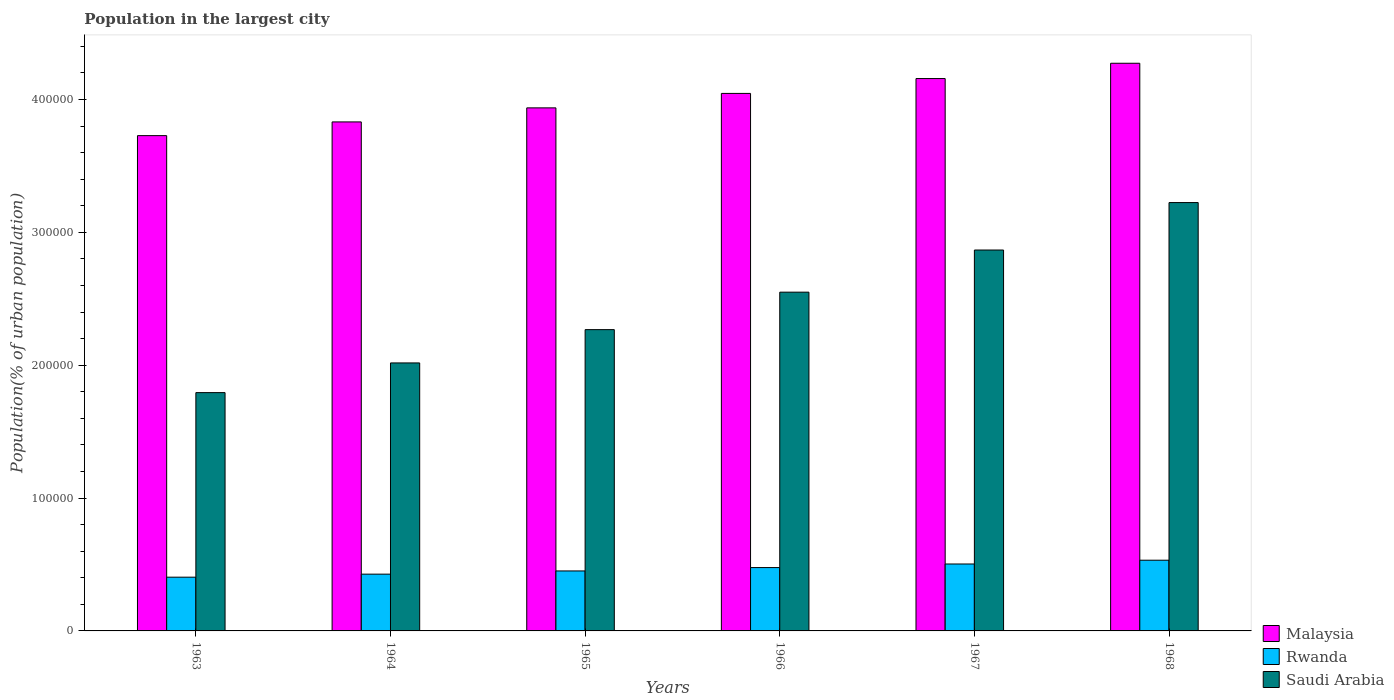Are the number of bars on each tick of the X-axis equal?
Provide a succinct answer. Yes. How many bars are there on the 2nd tick from the left?
Provide a succinct answer. 3. What is the label of the 2nd group of bars from the left?
Your answer should be very brief. 1964. In how many cases, is the number of bars for a given year not equal to the number of legend labels?
Your answer should be compact. 0. What is the population in the largest city in Saudi Arabia in 1967?
Keep it short and to the point. 2.87e+05. Across all years, what is the maximum population in the largest city in Malaysia?
Provide a short and direct response. 4.27e+05. Across all years, what is the minimum population in the largest city in Malaysia?
Make the answer very short. 3.73e+05. In which year was the population in the largest city in Rwanda maximum?
Make the answer very short. 1968. What is the total population in the largest city in Saudi Arabia in the graph?
Make the answer very short. 1.47e+06. What is the difference between the population in the largest city in Malaysia in 1963 and that in 1966?
Make the answer very short. -3.18e+04. What is the difference between the population in the largest city in Saudi Arabia in 1965 and the population in the largest city in Rwanda in 1966?
Offer a terse response. 1.79e+05. What is the average population in the largest city in Saudi Arabia per year?
Give a very brief answer. 2.45e+05. In the year 1964, what is the difference between the population in the largest city in Malaysia and population in the largest city in Rwanda?
Give a very brief answer. 3.40e+05. In how many years, is the population in the largest city in Rwanda greater than 180000 %?
Provide a short and direct response. 0. What is the ratio of the population in the largest city in Rwanda in 1966 to that in 1968?
Your response must be concise. 0.9. Is the population in the largest city in Saudi Arabia in 1963 less than that in 1964?
Your answer should be compact. Yes. What is the difference between the highest and the second highest population in the largest city in Malaysia?
Your response must be concise. 1.15e+04. What is the difference between the highest and the lowest population in the largest city in Rwanda?
Offer a terse response. 1.28e+04. Is the sum of the population in the largest city in Rwanda in 1966 and 1967 greater than the maximum population in the largest city in Saudi Arabia across all years?
Provide a succinct answer. No. What does the 2nd bar from the left in 1963 represents?
Give a very brief answer. Rwanda. What does the 2nd bar from the right in 1964 represents?
Provide a short and direct response. Rwanda. Is it the case that in every year, the sum of the population in the largest city in Saudi Arabia and population in the largest city in Malaysia is greater than the population in the largest city in Rwanda?
Ensure brevity in your answer.  Yes. Are all the bars in the graph horizontal?
Offer a terse response. No. Where does the legend appear in the graph?
Keep it short and to the point. Bottom right. How many legend labels are there?
Keep it short and to the point. 3. How are the legend labels stacked?
Your answer should be compact. Vertical. What is the title of the graph?
Your answer should be very brief. Population in the largest city. Does "Isle of Man" appear as one of the legend labels in the graph?
Offer a very short reply. No. What is the label or title of the X-axis?
Your response must be concise. Years. What is the label or title of the Y-axis?
Your answer should be very brief. Population(% of urban population). What is the Population(% of urban population) of Malaysia in 1963?
Offer a terse response. 3.73e+05. What is the Population(% of urban population) in Rwanda in 1963?
Offer a very short reply. 4.05e+04. What is the Population(% of urban population) in Saudi Arabia in 1963?
Your answer should be very brief. 1.79e+05. What is the Population(% of urban population) of Malaysia in 1964?
Provide a succinct answer. 3.83e+05. What is the Population(% of urban population) of Rwanda in 1964?
Give a very brief answer. 4.27e+04. What is the Population(% of urban population) in Saudi Arabia in 1964?
Your response must be concise. 2.02e+05. What is the Population(% of urban population) of Malaysia in 1965?
Make the answer very short. 3.94e+05. What is the Population(% of urban population) of Rwanda in 1965?
Give a very brief answer. 4.51e+04. What is the Population(% of urban population) of Saudi Arabia in 1965?
Ensure brevity in your answer.  2.27e+05. What is the Population(% of urban population) in Malaysia in 1966?
Your answer should be compact. 4.05e+05. What is the Population(% of urban population) in Rwanda in 1966?
Provide a short and direct response. 4.77e+04. What is the Population(% of urban population) in Saudi Arabia in 1966?
Your answer should be very brief. 2.55e+05. What is the Population(% of urban population) in Malaysia in 1967?
Make the answer very short. 4.16e+05. What is the Population(% of urban population) of Rwanda in 1967?
Your answer should be compact. 5.04e+04. What is the Population(% of urban population) of Saudi Arabia in 1967?
Offer a very short reply. 2.87e+05. What is the Population(% of urban population) of Malaysia in 1968?
Provide a succinct answer. 4.27e+05. What is the Population(% of urban population) in Rwanda in 1968?
Provide a short and direct response. 5.32e+04. What is the Population(% of urban population) of Saudi Arabia in 1968?
Your response must be concise. 3.22e+05. Across all years, what is the maximum Population(% of urban population) of Malaysia?
Make the answer very short. 4.27e+05. Across all years, what is the maximum Population(% of urban population) of Rwanda?
Offer a very short reply. 5.32e+04. Across all years, what is the maximum Population(% of urban population) in Saudi Arabia?
Provide a succinct answer. 3.22e+05. Across all years, what is the minimum Population(% of urban population) in Malaysia?
Give a very brief answer. 3.73e+05. Across all years, what is the minimum Population(% of urban population) of Rwanda?
Your answer should be compact. 4.05e+04. Across all years, what is the minimum Population(% of urban population) in Saudi Arabia?
Provide a succinct answer. 1.79e+05. What is the total Population(% of urban population) of Malaysia in the graph?
Keep it short and to the point. 2.40e+06. What is the total Population(% of urban population) in Rwanda in the graph?
Offer a very short reply. 2.80e+05. What is the total Population(% of urban population) of Saudi Arabia in the graph?
Give a very brief answer. 1.47e+06. What is the difference between the Population(% of urban population) of Malaysia in 1963 and that in 1964?
Keep it short and to the point. -1.03e+04. What is the difference between the Population(% of urban population) in Rwanda in 1963 and that in 1964?
Your response must be concise. -2284. What is the difference between the Population(% of urban population) of Saudi Arabia in 1963 and that in 1964?
Give a very brief answer. -2.23e+04. What is the difference between the Population(% of urban population) of Malaysia in 1963 and that in 1965?
Provide a succinct answer. -2.09e+04. What is the difference between the Population(% of urban population) of Rwanda in 1963 and that in 1965?
Keep it short and to the point. -4690. What is the difference between the Population(% of urban population) of Saudi Arabia in 1963 and that in 1965?
Offer a terse response. -4.74e+04. What is the difference between the Population(% of urban population) in Malaysia in 1963 and that in 1966?
Make the answer very short. -3.18e+04. What is the difference between the Population(% of urban population) of Rwanda in 1963 and that in 1966?
Provide a succinct answer. -7235. What is the difference between the Population(% of urban population) in Saudi Arabia in 1963 and that in 1966?
Your answer should be very brief. -7.56e+04. What is the difference between the Population(% of urban population) in Malaysia in 1963 and that in 1967?
Your response must be concise. -4.30e+04. What is the difference between the Population(% of urban population) of Rwanda in 1963 and that in 1967?
Offer a very short reply. -9924. What is the difference between the Population(% of urban population) of Saudi Arabia in 1963 and that in 1967?
Your answer should be very brief. -1.07e+05. What is the difference between the Population(% of urban population) of Malaysia in 1963 and that in 1968?
Your response must be concise. -5.45e+04. What is the difference between the Population(% of urban population) in Rwanda in 1963 and that in 1968?
Offer a terse response. -1.28e+04. What is the difference between the Population(% of urban population) of Saudi Arabia in 1963 and that in 1968?
Provide a succinct answer. -1.43e+05. What is the difference between the Population(% of urban population) in Malaysia in 1964 and that in 1965?
Give a very brief answer. -1.06e+04. What is the difference between the Population(% of urban population) in Rwanda in 1964 and that in 1965?
Your answer should be compact. -2406. What is the difference between the Population(% of urban population) in Saudi Arabia in 1964 and that in 1965?
Offer a terse response. -2.51e+04. What is the difference between the Population(% of urban population) of Malaysia in 1964 and that in 1966?
Your answer should be compact. -2.15e+04. What is the difference between the Population(% of urban population) in Rwanda in 1964 and that in 1966?
Make the answer very short. -4951. What is the difference between the Population(% of urban population) in Saudi Arabia in 1964 and that in 1966?
Your response must be concise. -5.33e+04. What is the difference between the Population(% of urban population) of Malaysia in 1964 and that in 1967?
Provide a succinct answer. -3.26e+04. What is the difference between the Population(% of urban population) in Rwanda in 1964 and that in 1967?
Offer a very short reply. -7640. What is the difference between the Population(% of urban population) in Saudi Arabia in 1964 and that in 1967?
Offer a very short reply. -8.50e+04. What is the difference between the Population(% of urban population) of Malaysia in 1964 and that in 1968?
Give a very brief answer. -4.42e+04. What is the difference between the Population(% of urban population) of Rwanda in 1964 and that in 1968?
Make the answer very short. -1.05e+04. What is the difference between the Population(% of urban population) of Saudi Arabia in 1964 and that in 1968?
Offer a very short reply. -1.21e+05. What is the difference between the Population(% of urban population) in Malaysia in 1965 and that in 1966?
Your answer should be compact. -1.09e+04. What is the difference between the Population(% of urban population) of Rwanda in 1965 and that in 1966?
Give a very brief answer. -2545. What is the difference between the Population(% of urban population) in Saudi Arabia in 1965 and that in 1966?
Your response must be concise. -2.82e+04. What is the difference between the Population(% of urban population) of Malaysia in 1965 and that in 1967?
Offer a terse response. -2.21e+04. What is the difference between the Population(% of urban population) in Rwanda in 1965 and that in 1967?
Keep it short and to the point. -5234. What is the difference between the Population(% of urban population) of Saudi Arabia in 1965 and that in 1967?
Ensure brevity in your answer.  -5.99e+04. What is the difference between the Population(% of urban population) in Malaysia in 1965 and that in 1968?
Your answer should be very brief. -3.36e+04. What is the difference between the Population(% of urban population) of Rwanda in 1965 and that in 1968?
Keep it short and to the point. -8077. What is the difference between the Population(% of urban population) of Saudi Arabia in 1965 and that in 1968?
Provide a succinct answer. -9.56e+04. What is the difference between the Population(% of urban population) of Malaysia in 1966 and that in 1967?
Offer a very short reply. -1.12e+04. What is the difference between the Population(% of urban population) in Rwanda in 1966 and that in 1967?
Make the answer very short. -2689. What is the difference between the Population(% of urban population) of Saudi Arabia in 1966 and that in 1967?
Your answer should be very brief. -3.17e+04. What is the difference between the Population(% of urban population) in Malaysia in 1966 and that in 1968?
Give a very brief answer. -2.27e+04. What is the difference between the Population(% of urban population) of Rwanda in 1966 and that in 1968?
Keep it short and to the point. -5532. What is the difference between the Population(% of urban population) of Saudi Arabia in 1966 and that in 1968?
Offer a very short reply. -6.74e+04. What is the difference between the Population(% of urban population) in Malaysia in 1967 and that in 1968?
Provide a short and direct response. -1.15e+04. What is the difference between the Population(% of urban population) in Rwanda in 1967 and that in 1968?
Your answer should be very brief. -2843. What is the difference between the Population(% of urban population) in Saudi Arabia in 1967 and that in 1968?
Your answer should be very brief. -3.57e+04. What is the difference between the Population(% of urban population) in Malaysia in 1963 and the Population(% of urban population) in Rwanda in 1964?
Make the answer very short. 3.30e+05. What is the difference between the Population(% of urban population) in Malaysia in 1963 and the Population(% of urban population) in Saudi Arabia in 1964?
Keep it short and to the point. 1.71e+05. What is the difference between the Population(% of urban population) of Rwanda in 1963 and the Population(% of urban population) of Saudi Arabia in 1964?
Provide a short and direct response. -1.61e+05. What is the difference between the Population(% of urban population) in Malaysia in 1963 and the Population(% of urban population) in Rwanda in 1965?
Offer a terse response. 3.28e+05. What is the difference between the Population(% of urban population) of Malaysia in 1963 and the Population(% of urban population) of Saudi Arabia in 1965?
Keep it short and to the point. 1.46e+05. What is the difference between the Population(% of urban population) in Rwanda in 1963 and the Population(% of urban population) in Saudi Arabia in 1965?
Provide a short and direct response. -1.86e+05. What is the difference between the Population(% of urban population) in Malaysia in 1963 and the Population(% of urban population) in Rwanda in 1966?
Offer a very short reply. 3.25e+05. What is the difference between the Population(% of urban population) of Malaysia in 1963 and the Population(% of urban population) of Saudi Arabia in 1966?
Provide a succinct answer. 1.18e+05. What is the difference between the Population(% of urban population) of Rwanda in 1963 and the Population(% of urban population) of Saudi Arabia in 1966?
Keep it short and to the point. -2.15e+05. What is the difference between the Population(% of urban population) in Malaysia in 1963 and the Population(% of urban population) in Rwanda in 1967?
Your answer should be compact. 3.22e+05. What is the difference between the Population(% of urban population) in Malaysia in 1963 and the Population(% of urban population) in Saudi Arabia in 1967?
Keep it short and to the point. 8.61e+04. What is the difference between the Population(% of urban population) in Rwanda in 1963 and the Population(% of urban population) in Saudi Arabia in 1967?
Offer a terse response. -2.46e+05. What is the difference between the Population(% of urban population) of Malaysia in 1963 and the Population(% of urban population) of Rwanda in 1968?
Provide a short and direct response. 3.20e+05. What is the difference between the Population(% of urban population) of Malaysia in 1963 and the Population(% of urban population) of Saudi Arabia in 1968?
Offer a very short reply. 5.04e+04. What is the difference between the Population(% of urban population) in Rwanda in 1963 and the Population(% of urban population) in Saudi Arabia in 1968?
Provide a short and direct response. -2.82e+05. What is the difference between the Population(% of urban population) of Malaysia in 1964 and the Population(% of urban population) of Rwanda in 1965?
Make the answer very short. 3.38e+05. What is the difference between the Population(% of urban population) in Malaysia in 1964 and the Population(% of urban population) in Saudi Arabia in 1965?
Keep it short and to the point. 1.56e+05. What is the difference between the Population(% of urban population) in Rwanda in 1964 and the Population(% of urban population) in Saudi Arabia in 1965?
Give a very brief answer. -1.84e+05. What is the difference between the Population(% of urban population) in Malaysia in 1964 and the Population(% of urban population) in Rwanda in 1966?
Keep it short and to the point. 3.35e+05. What is the difference between the Population(% of urban population) of Malaysia in 1964 and the Population(% of urban population) of Saudi Arabia in 1966?
Offer a very short reply. 1.28e+05. What is the difference between the Population(% of urban population) in Rwanda in 1964 and the Population(% of urban population) in Saudi Arabia in 1966?
Provide a succinct answer. -2.12e+05. What is the difference between the Population(% of urban population) in Malaysia in 1964 and the Population(% of urban population) in Rwanda in 1967?
Offer a very short reply. 3.33e+05. What is the difference between the Population(% of urban population) in Malaysia in 1964 and the Population(% of urban population) in Saudi Arabia in 1967?
Your response must be concise. 9.64e+04. What is the difference between the Population(% of urban population) in Rwanda in 1964 and the Population(% of urban population) in Saudi Arabia in 1967?
Your answer should be compact. -2.44e+05. What is the difference between the Population(% of urban population) in Malaysia in 1964 and the Population(% of urban population) in Rwanda in 1968?
Make the answer very short. 3.30e+05. What is the difference between the Population(% of urban population) of Malaysia in 1964 and the Population(% of urban population) of Saudi Arabia in 1968?
Offer a very short reply. 6.07e+04. What is the difference between the Population(% of urban population) in Rwanda in 1964 and the Population(% of urban population) in Saudi Arabia in 1968?
Ensure brevity in your answer.  -2.80e+05. What is the difference between the Population(% of urban population) of Malaysia in 1965 and the Population(% of urban population) of Rwanda in 1966?
Provide a succinct answer. 3.46e+05. What is the difference between the Population(% of urban population) in Malaysia in 1965 and the Population(% of urban population) in Saudi Arabia in 1966?
Offer a terse response. 1.39e+05. What is the difference between the Population(% of urban population) of Rwanda in 1965 and the Population(% of urban population) of Saudi Arabia in 1966?
Provide a succinct answer. -2.10e+05. What is the difference between the Population(% of urban population) of Malaysia in 1965 and the Population(% of urban population) of Rwanda in 1967?
Provide a short and direct response. 3.43e+05. What is the difference between the Population(% of urban population) of Malaysia in 1965 and the Population(% of urban population) of Saudi Arabia in 1967?
Offer a terse response. 1.07e+05. What is the difference between the Population(% of urban population) of Rwanda in 1965 and the Population(% of urban population) of Saudi Arabia in 1967?
Offer a very short reply. -2.42e+05. What is the difference between the Population(% of urban population) of Malaysia in 1965 and the Population(% of urban population) of Rwanda in 1968?
Your answer should be very brief. 3.40e+05. What is the difference between the Population(% of urban population) of Malaysia in 1965 and the Population(% of urban population) of Saudi Arabia in 1968?
Keep it short and to the point. 7.13e+04. What is the difference between the Population(% of urban population) in Rwanda in 1965 and the Population(% of urban population) in Saudi Arabia in 1968?
Offer a terse response. -2.77e+05. What is the difference between the Population(% of urban population) in Malaysia in 1966 and the Population(% of urban population) in Rwanda in 1967?
Provide a short and direct response. 3.54e+05. What is the difference between the Population(% of urban population) in Malaysia in 1966 and the Population(% of urban population) in Saudi Arabia in 1967?
Your answer should be very brief. 1.18e+05. What is the difference between the Population(% of urban population) in Rwanda in 1966 and the Population(% of urban population) in Saudi Arabia in 1967?
Offer a very short reply. -2.39e+05. What is the difference between the Population(% of urban population) in Malaysia in 1966 and the Population(% of urban population) in Rwanda in 1968?
Offer a terse response. 3.51e+05. What is the difference between the Population(% of urban population) of Malaysia in 1966 and the Population(% of urban population) of Saudi Arabia in 1968?
Provide a short and direct response. 8.22e+04. What is the difference between the Population(% of urban population) of Rwanda in 1966 and the Population(% of urban population) of Saudi Arabia in 1968?
Make the answer very short. -2.75e+05. What is the difference between the Population(% of urban population) in Malaysia in 1967 and the Population(% of urban population) in Rwanda in 1968?
Your answer should be very brief. 3.63e+05. What is the difference between the Population(% of urban population) of Malaysia in 1967 and the Population(% of urban population) of Saudi Arabia in 1968?
Provide a succinct answer. 9.34e+04. What is the difference between the Population(% of urban population) in Rwanda in 1967 and the Population(% of urban population) in Saudi Arabia in 1968?
Provide a short and direct response. -2.72e+05. What is the average Population(% of urban population) of Malaysia per year?
Ensure brevity in your answer.  4.00e+05. What is the average Population(% of urban population) of Rwanda per year?
Your answer should be compact. 4.66e+04. What is the average Population(% of urban population) in Saudi Arabia per year?
Keep it short and to the point. 2.45e+05. In the year 1963, what is the difference between the Population(% of urban population) in Malaysia and Population(% of urban population) in Rwanda?
Provide a short and direct response. 3.32e+05. In the year 1963, what is the difference between the Population(% of urban population) of Malaysia and Population(% of urban population) of Saudi Arabia?
Offer a terse response. 1.93e+05. In the year 1963, what is the difference between the Population(% of urban population) of Rwanda and Population(% of urban population) of Saudi Arabia?
Offer a terse response. -1.39e+05. In the year 1964, what is the difference between the Population(% of urban population) of Malaysia and Population(% of urban population) of Rwanda?
Your answer should be compact. 3.40e+05. In the year 1964, what is the difference between the Population(% of urban population) of Malaysia and Population(% of urban population) of Saudi Arabia?
Ensure brevity in your answer.  1.81e+05. In the year 1964, what is the difference between the Population(% of urban population) of Rwanda and Population(% of urban population) of Saudi Arabia?
Your response must be concise. -1.59e+05. In the year 1965, what is the difference between the Population(% of urban population) of Malaysia and Population(% of urban population) of Rwanda?
Give a very brief answer. 3.49e+05. In the year 1965, what is the difference between the Population(% of urban population) in Malaysia and Population(% of urban population) in Saudi Arabia?
Ensure brevity in your answer.  1.67e+05. In the year 1965, what is the difference between the Population(% of urban population) in Rwanda and Population(% of urban population) in Saudi Arabia?
Make the answer very short. -1.82e+05. In the year 1966, what is the difference between the Population(% of urban population) in Malaysia and Population(% of urban population) in Rwanda?
Your answer should be compact. 3.57e+05. In the year 1966, what is the difference between the Population(% of urban population) of Malaysia and Population(% of urban population) of Saudi Arabia?
Your answer should be compact. 1.50e+05. In the year 1966, what is the difference between the Population(% of urban population) in Rwanda and Population(% of urban population) in Saudi Arabia?
Provide a short and direct response. -2.07e+05. In the year 1967, what is the difference between the Population(% of urban population) in Malaysia and Population(% of urban population) in Rwanda?
Provide a succinct answer. 3.65e+05. In the year 1967, what is the difference between the Population(% of urban population) of Malaysia and Population(% of urban population) of Saudi Arabia?
Provide a short and direct response. 1.29e+05. In the year 1967, what is the difference between the Population(% of urban population) of Rwanda and Population(% of urban population) of Saudi Arabia?
Your answer should be very brief. -2.36e+05. In the year 1968, what is the difference between the Population(% of urban population) of Malaysia and Population(% of urban population) of Rwanda?
Offer a terse response. 3.74e+05. In the year 1968, what is the difference between the Population(% of urban population) of Malaysia and Population(% of urban population) of Saudi Arabia?
Ensure brevity in your answer.  1.05e+05. In the year 1968, what is the difference between the Population(% of urban population) in Rwanda and Population(% of urban population) in Saudi Arabia?
Offer a terse response. -2.69e+05. What is the ratio of the Population(% of urban population) of Malaysia in 1963 to that in 1964?
Provide a succinct answer. 0.97. What is the ratio of the Population(% of urban population) of Rwanda in 1963 to that in 1964?
Your response must be concise. 0.95. What is the ratio of the Population(% of urban population) in Saudi Arabia in 1963 to that in 1964?
Give a very brief answer. 0.89. What is the ratio of the Population(% of urban population) of Malaysia in 1963 to that in 1965?
Your response must be concise. 0.95. What is the ratio of the Population(% of urban population) of Rwanda in 1963 to that in 1965?
Offer a very short reply. 0.9. What is the ratio of the Population(% of urban population) in Saudi Arabia in 1963 to that in 1965?
Make the answer very short. 0.79. What is the ratio of the Population(% of urban population) in Malaysia in 1963 to that in 1966?
Provide a short and direct response. 0.92. What is the ratio of the Population(% of urban population) in Rwanda in 1963 to that in 1966?
Provide a short and direct response. 0.85. What is the ratio of the Population(% of urban population) of Saudi Arabia in 1963 to that in 1966?
Your answer should be very brief. 0.7. What is the ratio of the Population(% of urban population) in Malaysia in 1963 to that in 1967?
Provide a short and direct response. 0.9. What is the ratio of the Population(% of urban population) in Rwanda in 1963 to that in 1967?
Your answer should be compact. 0.8. What is the ratio of the Population(% of urban population) in Saudi Arabia in 1963 to that in 1967?
Give a very brief answer. 0.63. What is the ratio of the Population(% of urban population) of Malaysia in 1963 to that in 1968?
Your answer should be very brief. 0.87. What is the ratio of the Population(% of urban population) in Rwanda in 1963 to that in 1968?
Your answer should be compact. 0.76. What is the ratio of the Population(% of urban population) of Saudi Arabia in 1963 to that in 1968?
Give a very brief answer. 0.56. What is the ratio of the Population(% of urban population) in Malaysia in 1964 to that in 1965?
Your response must be concise. 0.97. What is the ratio of the Population(% of urban population) in Rwanda in 1964 to that in 1965?
Offer a very short reply. 0.95. What is the ratio of the Population(% of urban population) of Saudi Arabia in 1964 to that in 1965?
Keep it short and to the point. 0.89. What is the ratio of the Population(% of urban population) of Malaysia in 1964 to that in 1966?
Make the answer very short. 0.95. What is the ratio of the Population(% of urban population) of Rwanda in 1964 to that in 1966?
Keep it short and to the point. 0.9. What is the ratio of the Population(% of urban population) of Saudi Arabia in 1964 to that in 1966?
Give a very brief answer. 0.79. What is the ratio of the Population(% of urban population) in Malaysia in 1964 to that in 1967?
Ensure brevity in your answer.  0.92. What is the ratio of the Population(% of urban population) in Rwanda in 1964 to that in 1967?
Provide a succinct answer. 0.85. What is the ratio of the Population(% of urban population) in Saudi Arabia in 1964 to that in 1967?
Offer a terse response. 0.7. What is the ratio of the Population(% of urban population) in Malaysia in 1964 to that in 1968?
Keep it short and to the point. 0.9. What is the ratio of the Population(% of urban population) in Rwanda in 1964 to that in 1968?
Your response must be concise. 0.8. What is the ratio of the Population(% of urban population) in Saudi Arabia in 1964 to that in 1968?
Your answer should be compact. 0.63. What is the ratio of the Population(% of urban population) of Malaysia in 1965 to that in 1966?
Your answer should be compact. 0.97. What is the ratio of the Population(% of urban population) of Rwanda in 1965 to that in 1966?
Give a very brief answer. 0.95. What is the ratio of the Population(% of urban population) in Saudi Arabia in 1965 to that in 1966?
Your answer should be compact. 0.89. What is the ratio of the Population(% of urban population) in Malaysia in 1965 to that in 1967?
Give a very brief answer. 0.95. What is the ratio of the Population(% of urban population) of Rwanda in 1965 to that in 1967?
Provide a succinct answer. 0.9. What is the ratio of the Population(% of urban population) in Saudi Arabia in 1965 to that in 1967?
Make the answer very short. 0.79. What is the ratio of the Population(% of urban population) of Malaysia in 1965 to that in 1968?
Provide a short and direct response. 0.92. What is the ratio of the Population(% of urban population) in Rwanda in 1965 to that in 1968?
Ensure brevity in your answer.  0.85. What is the ratio of the Population(% of urban population) in Saudi Arabia in 1965 to that in 1968?
Your answer should be compact. 0.7. What is the ratio of the Population(% of urban population) of Malaysia in 1966 to that in 1967?
Make the answer very short. 0.97. What is the ratio of the Population(% of urban population) of Rwanda in 1966 to that in 1967?
Make the answer very short. 0.95. What is the ratio of the Population(% of urban population) of Saudi Arabia in 1966 to that in 1967?
Provide a succinct answer. 0.89. What is the ratio of the Population(% of urban population) of Malaysia in 1966 to that in 1968?
Make the answer very short. 0.95. What is the ratio of the Population(% of urban population) in Rwanda in 1966 to that in 1968?
Your answer should be very brief. 0.9. What is the ratio of the Population(% of urban population) in Saudi Arabia in 1966 to that in 1968?
Offer a terse response. 0.79. What is the ratio of the Population(% of urban population) in Malaysia in 1967 to that in 1968?
Ensure brevity in your answer.  0.97. What is the ratio of the Population(% of urban population) in Rwanda in 1967 to that in 1968?
Give a very brief answer. 0.95. What is the ratio of the Population(% of urban population) of Saudi Arabia in 1967 to that in 1968?
Ensure brevity in your answer.  0.89. What is the difference between the highest and the second highest Population(% of urban population) in Malaysia?
Offer a terse response. 1.15e+04. What is the difference between the highest and the second highest Population(% of urban population) of Rwanda?
Your response must be concise. 2843. What is the difference between the highest and the second highest Population(% of urban population) in Saudi Arabia?
Your answer should be compact. 3.57e+04. What is the difference between the highest and the lowest Population(% of urban population) in Malaysia?
Offer a terse response. 5.45e+04. What is the difference between the highest and the lowest Population(% of urban population) in Rwanda?
Ensure brevity in your answer.  1.28e+04. What is the difference between the highest and the lowest Population(% of urban population) in Saudi Arabia?
Ensure brevity in your answer.  1.43e+05. 